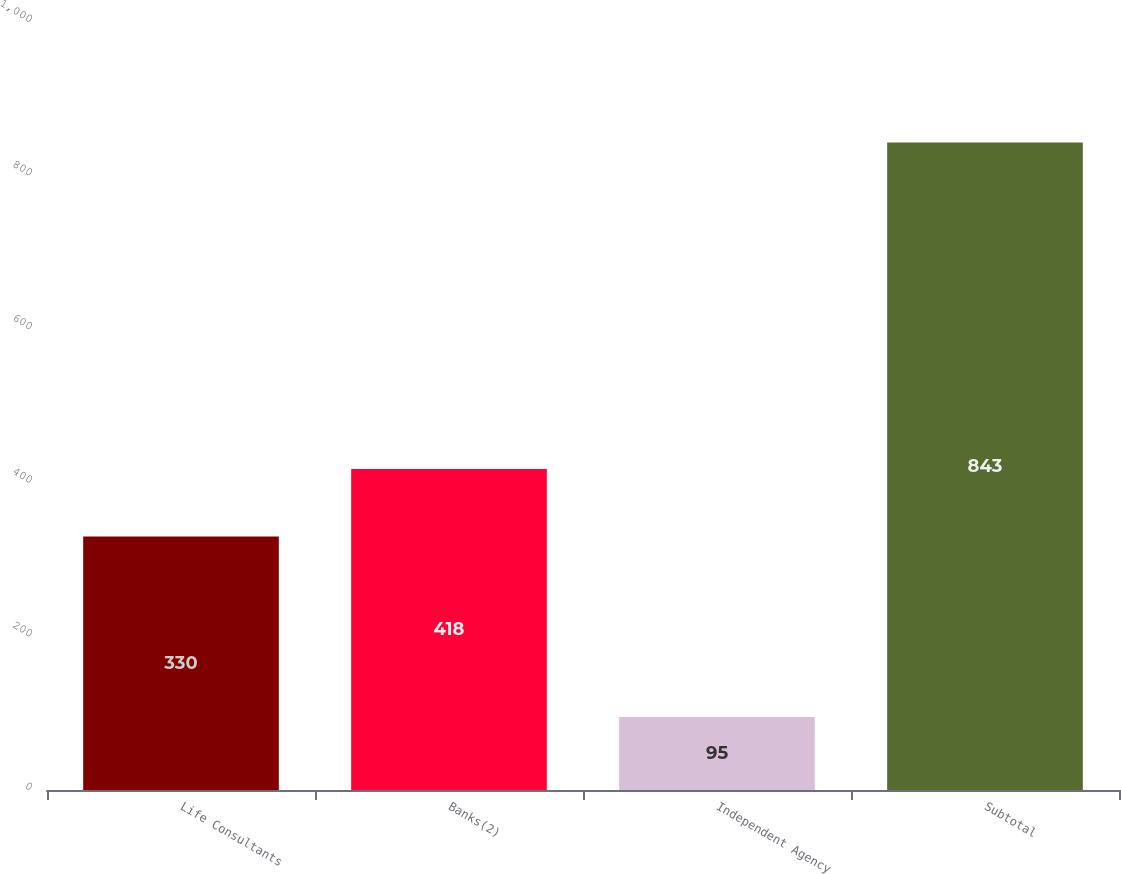Convert chart to OTSL. <chart><loc_0><loc_0><loc_500><loc_500><bar_chart><fcel>Life Consultants<fcel>Banks(2)<fcel>Independent Agency<fcel>Subtotal<nl><fcel>330<fcel>418<fcel>95<fcel>843<nl></chart> 